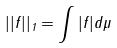Convert formula to latex. <formula><loc_0><loc_0><loc_500><loc_500>| | f | | _ { 1 } = \int | f | d \mu</formula> 